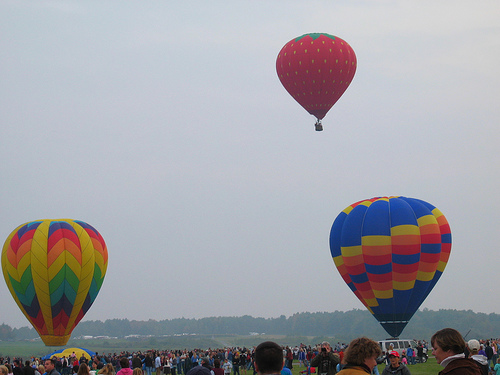<image>
Is there a parachute on the sky? No. The parachute is not positioned on the sky. They may be near each other, but the parachute is not supported by or resting on top of the sky. 